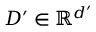<formula> <loc_0><loc_0><loc_500><loc_500>D ^ { \prime } \in \mathbb { R } ^ { d ^ { \prime } }</formula> 